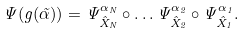<formula> <loc_0><loc_0><loc_500><loc_500>\Psi ( g ( \vec { \alpha } ) ) = \Psi ^ { \alpha _ { N } } _ { \hat { X } _ { N } } \circ \dots \Psi ^ { \alpha _ { 2 } } _ { \hat { X } _ { 2 } } \circ \Psi ^ { \alpha _ { 1 } } _ { \hat { X } _ { 1 } } .</formula> 